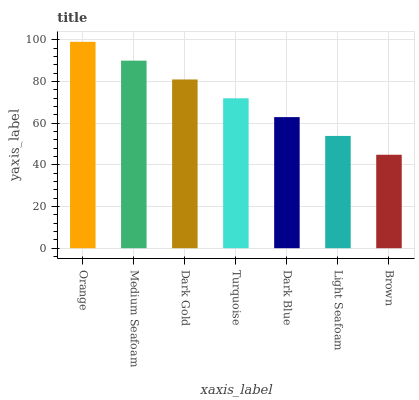Is Brown the minimum?
Answer yes or no. Yes. Is Orange the maximum?
Answer yes or no. Yes. Is Medium Seafoam the minimum?
Answer yes or no. No. Is Medium Seafoam the maximum?
Answer yes or no. No. Is Orange greater than Medium Seafoam?
Answer yes or no. Yes. Is Medium Seafoam less than Orange?
Answer yes or no. Yes. Is Medium Seafoam greater than Orange?
Answer yes or no. No. Is Orange less than Medium Seafoam?
Answer yes or no. No. Is Turquoise the high median?
Answer yes or no. Yes. Is Turquoise the low median?
Answer yes or no. Yes. Is Dark Gold the high median?
Answer yes or no. No. Is Dark Blue the low median?
Answer yes or no. No. 